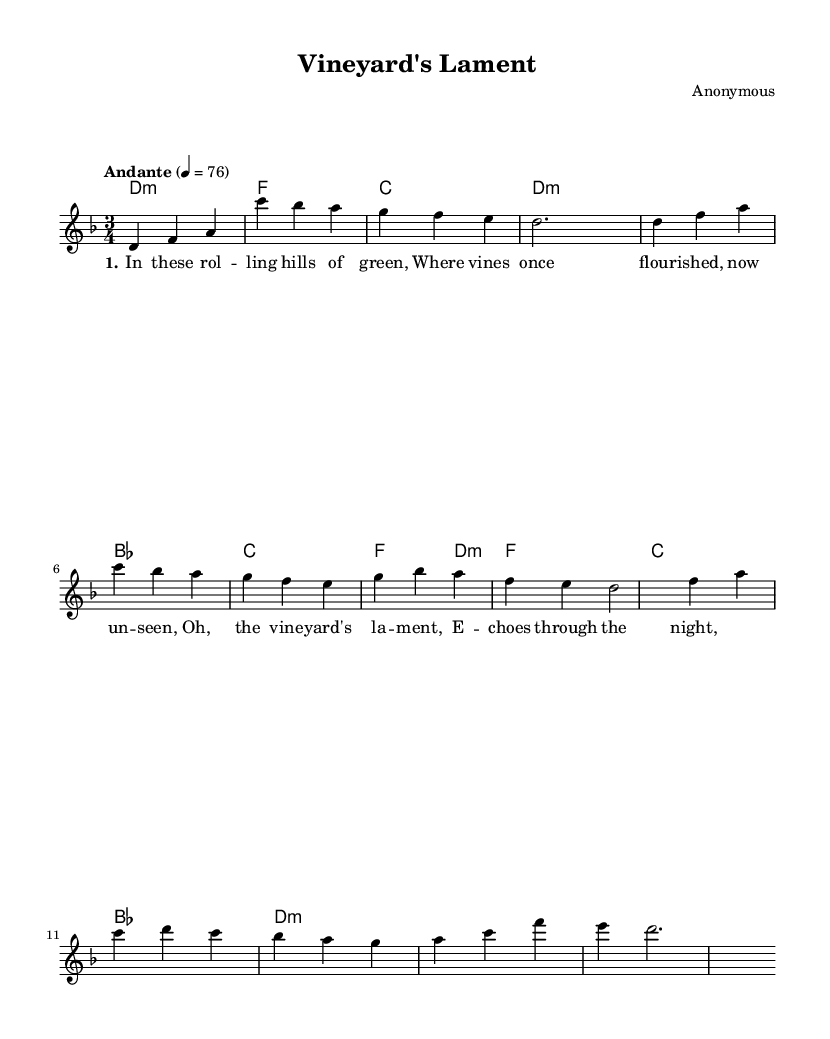What is the key signature of this music? The key signature is two flats, which indicates it is in the key of D minor. This can be deduced from the global settings where it states "\key d \minor".
Answer: D minor What is the time signature of this music? The time signature is three beats per measure, which is shown in the global settings with "\time 3/4". This indicates a waltz-like feel common in folk music.
Answer: 3/4 What is the tempo marking indicated in the music? The tempo marking is "Andante" at a metronome mark of 76 beats per minute, given in the global section. The term "Andante" implies a moderate walking pace.
Answer: Andante, 76 How many measures are in the intro section? The intro consists of four measures, as indicated by the four sets of notes presented before the first verse begins. Each measure is counted as separated by the vertical bar lines.
Answer: 4 What is the central theme presented in the first verse? The first verse discusses the struggles of vineyards, hinting at themes of decline and loss in the context of changing climates, as indicated by the lyrics. This content aligns with contemporary folk traditions that reflect on real-life issues faced by communities.
Answer: Vineyard's lament What type of chord progression is used in the chorus? The chord progression in the chorus follows a standard pattern commonly found in folk music, offering a familiar sound. It uses D minor and C major chords, creating a sense of resolution and emotional depth.
Answer: D minor, C major What mood does the overall melody convey? The overall melody conveys a somber and reflective mood, as indicated by the choice of notes and minor key signature, suggesting a connection to the emotional struggles faced by vineyard owners in their narrative.
Answer: Somber, reflective 